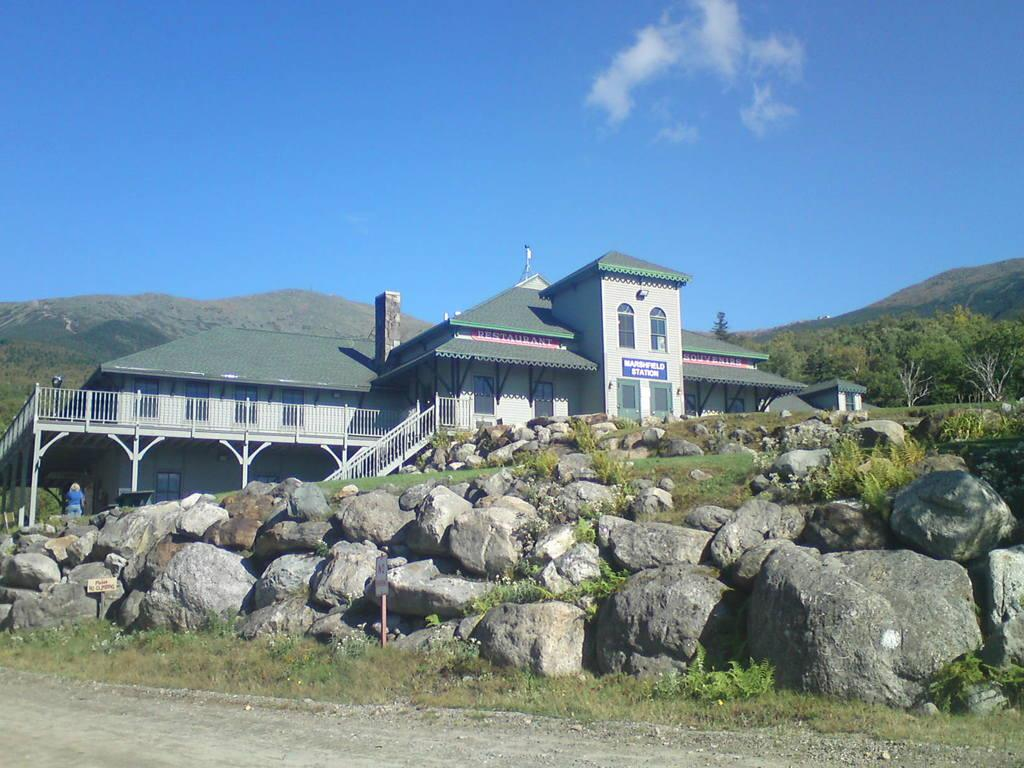What is the color and condition of the sky in the image? The sky is clear, blue, and slightly cloudy at the top of the image. What type of structure can be seen in the image? There is a house in the image. What type of vegetation is present in the image? There are many trees in the image. What geographical feature can be seen in the distance? There are mountains in the image. What type of board is being used to surf the current in the image? There is no board or current present in the image; it features a house, trees, mountains, and a clear, blue, and slightly cloudy sky. 